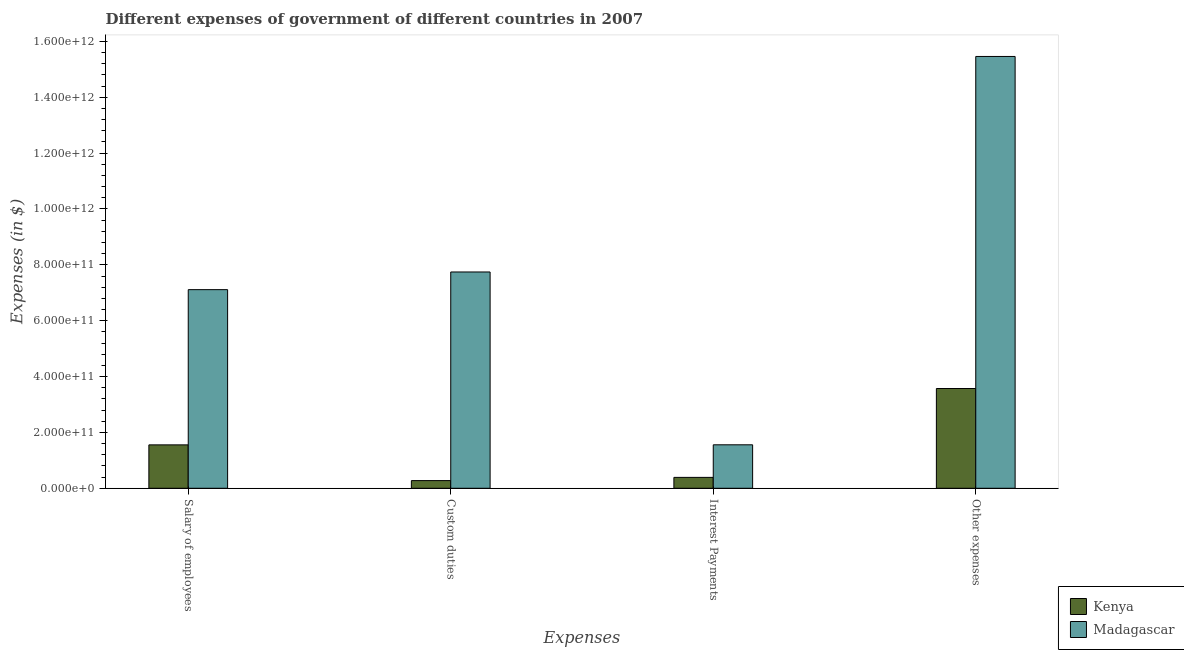How many different coloured bars are there?
Your response must be concise. 2. How many groups of bars are there?
Offer a terse response. 4. Are the number of bars on each tick of the X-axis equal?
Offer a very short reply. Yes. How many bars are there on the 3rd tick from the right?
Give a very brief answer. 2. What is the label of the 2nd group of bars from the left?
Keep it short and to the point. Custom duties. What is the amount spent on salary of employees in Kenya?
Provide a short and direct response. 1.55e+11. Across all countries, what is the maximum amount spent on interest payments?
Provide a succinct answer. 1.56e+11. Across all countries, what is the minimum amount spent on custom duties?
Ensure brevity in your answer.  2.75e+1. In which country was the amount spent on other expenses maximum?
Your answer should be compact. Madagascar. In which country was the amount spent on interest payments minimum?
Your answer should be very brief. Kenya. What is the total amount spent on salary of employees in the graph?
Your answer should be very brief. 8.67e+11. What is the difference between the amount spent on custom duties in Kenya and that in Madagascar?
Your response must be concise. -7.47e+11. What is the difference between the amount spent on salary of employees in Kenya and the amount spent on interest payments in Madagascar?
Your answer should be compact. -2.43e+08. What is the average amount spent on salary of employees per country?
Offer a terse response. 4.33e+11. What is the difference between the amount spent on other expenses and amount spent on salary of employees in Kenya?
Your answer should be very brief. 2.02e+11. What is the ratio of the amount spent on salary of employees in Kenya to that in Madagascar?
Your answer should be compact. 0.22. Is the amount spent on custom duties in Kenya less than that in Madagascar?
Give a very brief answer. Yes. Is the difference between the amount spent on other expenses in Kenya and Madagascar greater than the difference between the amount spent on interest payments in Kenya and Madagascar?
Give a very brief answer. No. What is the difference between the highest and the second highest amount spent on custom duties?
Make the answer very short. 7.47e+11. What is the difference between the highest and the lowest amount spent on other expenses?
Make the answer very short. 1.19e+12. In how many countries, is the amount spent on custom duties greater than the average amount spent on custom duties taken over all countries?
Your answer should be compact. 1. Is the sum of the amount spent on custom duties in Kenya and Madagascar greater than the maximum amount spent on salary of employees across all countries?
Your answer should be very brief. Yes. Is it the case that in every country, the sum of the amount spent on custom duties and amount spent on salary of employees is greater than the sum of amount spent on other expenses and amount spent on interest payments?
Ensure brevity in your answer.  No. What does the 2nd bar from the left in Salary of employees represents?
Keep it short and to the point. Madagascar. What does the 2nd bar from the right in Salary of employees represents?
Provide a succinct answer. Kenya. Are all the bars in the graph horizontal?
Your response must be concise. No. What is the difference between two consecutive major ticks on the Y-axis?
Your response must be concise. 2.00e+11. Does the graph contain any zero values?
Offer a terse response. No. Does the graph contain grids?
Give a very brief answer. No. Where does the legend appear in the graph?
Keep it short and to the point. Bottom right. How are the legend labels stacked?
Give a very brief answer. Vertical. What is the title of the graph?
Make the answer very short. Different expenses of government of different countries in 2007. What is the label or title of the X-axis?
Keep it short and to the point. Expenses. What is the label or title of the Y-axis?
Ensure brevity in your answer.  Expenses (in $). What is the Expenses (in $) of Kenya in Salary of employees?
Give a very brief answer. 1.55e+11. What is the Expenses (in $) of Madagascar in Salary of employees?
Your answer should be compact. 7.11e+11. What is the Expenses (in $) of Kenya in Custom duties?
Provide a short and direct response. 2.75e+1. What is the Expenses (in $) in Madagascar in Custom duties?
Your answer should be compact. 7.74e+11. What is the Expenses (in $) of Kenya in Interest Payments?
Your answer should be compact. 3.90e+1. What is the Expenses (in $) of Madagascar in Interest Payments?
Keep it short and to the point. 1.56e+11. What is the Expenses (in $) in Kenya in Other expenses?
Your answer should be compact. 3.57e+11. What is the Expenses (in $) of Madagascar in Other expenses?
Make the answer very short. 1.55e+12. Across all Expenses, what is the maximum Expenses (in $) in Kenya?
Make the answer very short. 3.57e+11. Across all Expenses, what is the maximum Expenses (in $) in Madagascar?
Keep it short and to the point. 1.55e+12. Across all Expenses, what is the minimum Expenses (in $) of Kenya?
Provide a succinct answer. 2.75e+1. Across all Expenses, what is the minimum Expenses (in $) in Madagascar?
Keep it short and to the point. 1.56e+11. What is the total Expenses (in $) in Kenya in the graph?
Make the answer very short. 5.79e+11. What is the total Expenses (in $) of Madagascar in the graph?
Provide a short and direct response. 3.19e+12. What is the difference between the Expenses (in $) in Kenya in Salary of employees and that in Custom duties?
Offer a very short reply. 1.28e+11. What is the difference between the Expenses (in $) in Madagascar in Salary of employees and that in Custom duties?
Provide a succinct answer. -6.33e+1. What is the difference between the Expenses (in $) in Kenya in Salary of employees and that in Interest Payments?
Offer a very short reply. 1.16e+11. What is the difference between the Expenses (in $) of Madagascar in Salary of employees and that in Interest Payments?
Give a very brief answer. 5.56e+11. What is the difference between the Expenses (in $) of Kenya in Salary of employees and that in Other expenses?
Offer a very short reply. -2.02e+11. What is the difference between the Expenses (in $) of Madagascar in Salary of employees and that in Other expenses?
Your answer should be compact. -8.35e+11. What is the difference between the Expenses (in $) of Kenya in Custom duties and that in Interest Payments?
Your answer should be compact. -1.15e+1. What is the difference between the Expenses (in $) of Madagascar in Custom duties and that in Interest Payments?
Your response must be concise. 6.19e+11. What is the difference between the Expenses (in $) of Kenya in Custom duties and that in Other expenses?
Keep it short and to the point. -3.30e+11. What is the difference between the Expenses (in $) in Madagascar in Custom duties and that in Other expenses?
Provide a short and direct response. -7.72e+11. What is the difference between the Expenses (in $) in Kenya in Interest Payments and that in Other expenses?
Offer a very short reply. -3.18e+11. What is the difference between the Expenses (in $) in Madagascar in Interest Payments and that in Other expenses?
Make the answer very short. -1.39e+12. What is the difference between the Expenses (in $) in Kenya in Salary of employees and the Expenses (in $) in Madagascar in Custom duties?
Offer a very short reply. -6.19e+11. What is the difference between the Expenses (in $) in Kenya in Salary of employees and the Expenses (in $) in Madagascar in Interest Payments?
Give a very brief answer. -2.43e+08. What is the difference between the Expenses (in $) in Kenya in Salary of employees and the Expenses (in $) in Madagascar in Other expenses?
Your answer should be very brief. -1.39e+12. What is the difference between the Expenses (in $) in Kenya in Custom duties and the Expenses (in $) in Madagascar in Interest Payments?
Provide a short and direct response. -1.28e+11. What is the difference between the Expenses (in $) in Kenya in Custom duties and the Expenses (in $) in Madagascar in Other expenses?
Keep it short and to the point. -1.52e+12. What is the difference between the Expenses (in $) of Kenya in Interest Payments and the Expenses (in $) of Madagascar in Other expenses?
Make the answer very short. -1.51e+12. What is the average Expenses (in $) of Kenya per Expenses?
Provide a succinct answer. 1.45e+11. What is the average Expenses (in $) of Madagascar per Expenses?
Ensure brevity in your answer.  7.97e+11. What is the difference between the Expenses (in $) of Kenya and Expenses (in $) of Madagascar in Salary of employees?
Offer a very short reply. -5.56e+11. What is the difference between the Expenses (in $) in Kenya and Expenses (in $) in Madagascar in Custom duties?
Your answer should be very brief. -7.47e+11. What is the difference between the Expenses (in $) in Kenya and Expenses (in $) in Madagascar in Interest Payments?
Give a very brief answer. -1.17e+11. What is the difference between the Expenses (in $) in Kenya and Expenses (in $) in Madagascar in Other expenses?
Provide a short and direct response. -1.19e+12. What is the ratio of the Expenses (in $) of Kenya in Salary of employees to that in Custom duties?
Provide a short and direct response. 5.65. What is the ratio of the Expenses (in $) in Madagascar in Salary of employees to that in Custom duties?
Ensure brevity in your answer.  0.92. What is the ratio of the Expenses (in $) of Kenya in Salary of employees to that in Interest Payments?
Offer a terse response. 3.99. What is the ratio of the Expenses (in $) of Madagascar in Salary of employees to that in Interest Payments?
Keep it short and to the point. 4.57. What is the ratio of the Expenses (in $) of Kenya in Salary of employees to that in Other expenses?
Your answer should be very brief. 0.44. What is the ratio of the Expenses (in $) in Madagascar in Salary of employees to that in Other expenses?
Your answer should be very brief. 0.46. What is the ratio of the Expenses (in $) of Kenya in Custom duties to that in Interest Payments?
Keep it short and to the point. 0.71. What is the ratio of the Expenses (in $) in Madagascar in Custom duties to that in Interest Payments?
Make the answer very short. 4.98. What is the ratio of the Expenses (in $) of Kenya in Custom duties to that in Other expenses?
Your answer should be compact. 0.08. What is the ratio of the Expenses (in $) in Madagascar in Custom duties to that in Other expenses?
Offer a terse response. 0.5. What is the ratio of the Expenses (in $) of Kenya in Interest Payments to that in Other expenses?
Provide a short and direct response. 0.11. What is the ratio of the Expenses (in $) in Madagascar in Interest Payments to that in Other expenses?
Your answer should be very brief. 0.1. What is the difference between the highest and the second highest Expenses (in $) of Kenya?
Offer a terse response. 2.02e+11. What is the difference between the highest and the second highest Expenses (in $) of Madagascar?
Ensure brevity in your answer.  7.72e+11. What is the difference between the highest and the lowest Expenses (in $) of Kenya?
Your response must be concise. 3.30e+11. What is the difference between the highest and the lowest Expenses (in $) of Madagascar?
Offer a very short reply. 1.39e+12. 